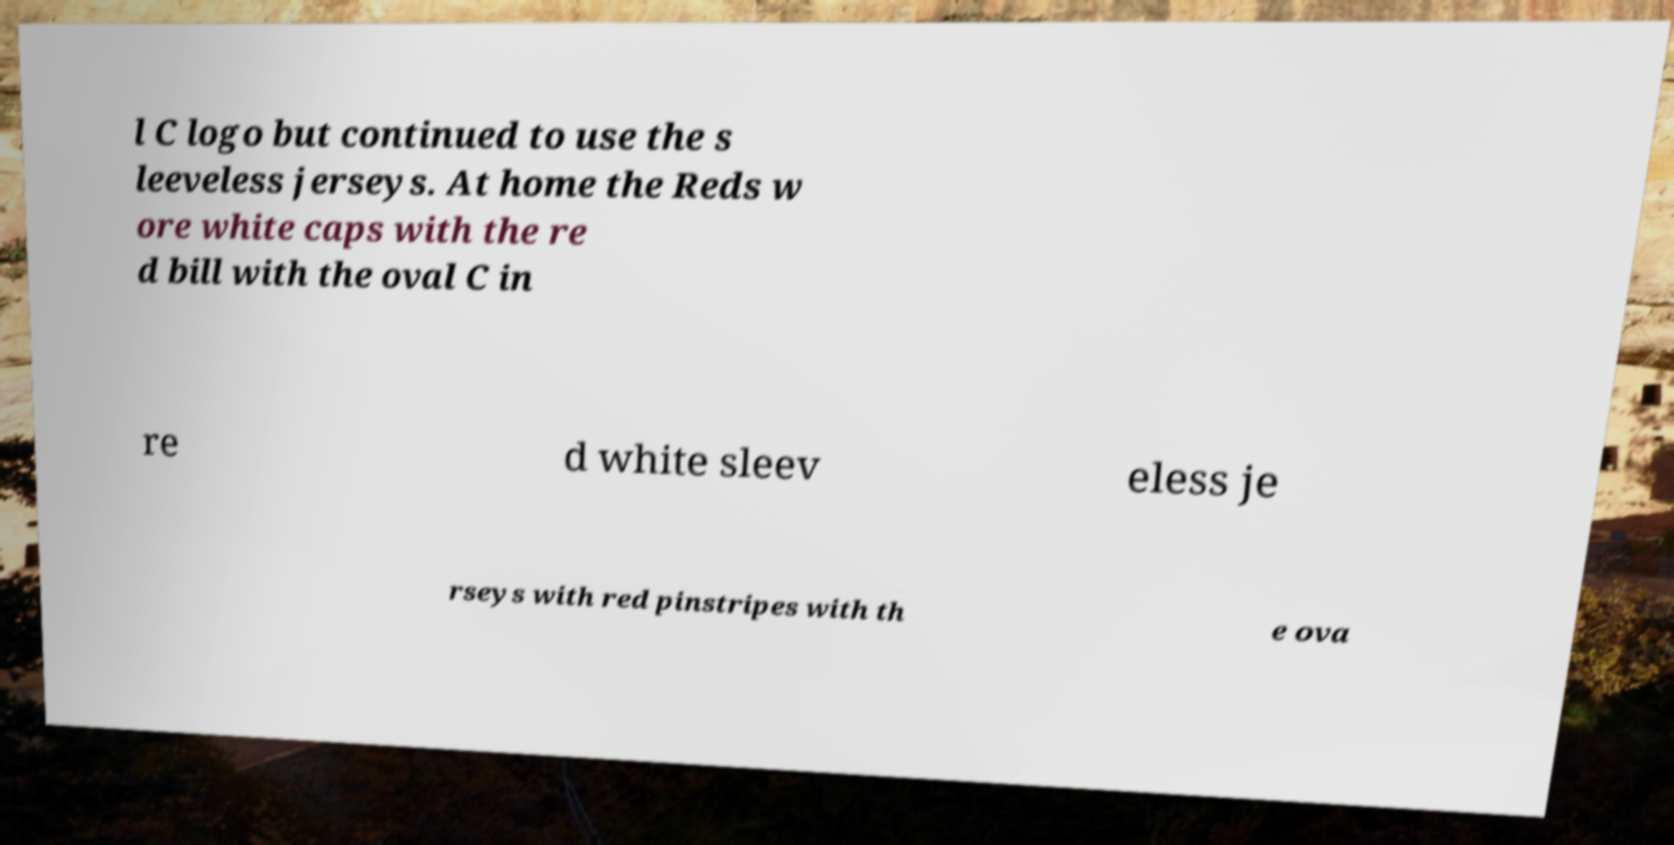I need the written content from this picture converted into text. Can you do that? l C logo but continued to use the s leeveless jerseys. At home the Reds w ore white caps with the re d bill with the oval C in re d white sleev eless je rseys with red pinstripes with th e ova 